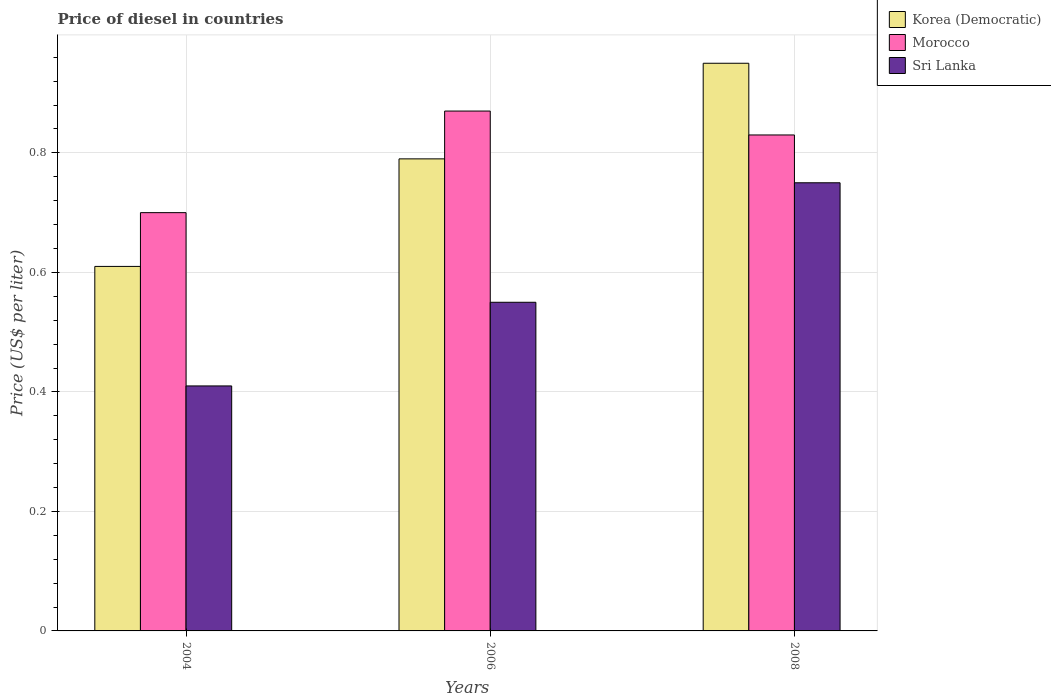Are the number of bars per tick equal to the number of legend labels?
Keep it short and to the point. Yes. Are the number of bars on each tick of the X-axis equal?
Provide a succinct answer. Yes. How many bars are there on the 1st tick from the left?
Provide a short and direct response. 3. What is the label of the 1st group of bars from the left?
Provide a short and direct response. 2004. In how many cases, is the number of bars for a given year not equal to the number of legend labels?
Offer a very short reply. 0. What is the price of diesel in Morocco in 2008?
Offer a terse response. 0.83. Across all years, what is the maximum price of diesel in Morocco?
Your answer should be compact. 0.87. Across all years, what is the minimum price of diesel in Korea (Democratic)?
Keep it short and to the point. 0.61. In which year was the price of diesel in Sri Lanka maximum?
Offer a terse response. 2008. What is the total price of diesel in Sri Lanka in the graph?
Offer a very short reply. 1.71. What is the difference between the price of diesel in Sri Lanka in 2004 and that in 2006?
Your answer should be very brief. -0.14. What is the difference between the price of diesel in Sri Lanka in 2008 and the price of diesel in Korea (Democratic) in 2006?
Your answer should be very brief. -0.04. What is the average price of diesel in Sri Lanka per year?
Provide a short and direct response. 0.57. In the year 2008, what is the difference between the price of diesel in Korea (Democratic) and price of diesel in Sri Lanka?
Ensure brevity in your answer.  0.2. What is the ratio of the price of diesel in Korea (Democratic) in 2004 to that in 2008?
Your answer should be compact. 0.64. Is the price of diesel in Korea (Democratic) in 2006 less than that in 2008?
Your response must be concise. Yes. Is the difference between the price of diesel in Korea (Democratic) in 2006 and 2008 greater than the difference between the price of diesel in Sri Lanka in 2006 and 2008?
Provide a succinct answer. Yes. What is the difference between the highest and the second highest price of diesel in Sri Lanka?
Ensure brevity in your answer.  0.2. What is the difference between the highest and the lowest price of diesel in Morocco?
Your answer should be compact. 0.17. What does the 3rd bar from the left in 2008 represents?
Your response must be concise. Sri Lanka. What does the 1st bar from the right in 2006 represents?
Offer a terse response. Sri Lanka. Is it the case that in every year, the sum of the price of diesel in Morocco and price of diesel in Korea (Democratic) is greater than the price of diesel in Sri Lanka?
Your answer should be very brief. Yes. How many years are there in the graph?
Your answer should be very brief. 3. Does the graph contain any zero values?
Ensure brevity in your answer.  No. Where does the legend appear in the graph?
Make the answer very short. Top right. What is the title of the graph?
Give a very brief answer. Price of diesel in countries. What is the label or title of the X-axis?
Your answer should be very brief. Years. What is the label or title of the Y-axis?
Your answer should be compact. Price (US$ per liter). What is the Price (US$ per liter) of Korea (Democratic) in 2004?
Your answer should be very brief. 0.61. What is the Price (US$ per liter) of Morocco in 2004?
Provide a succinct answer. 0.7. What is the Price (US$ per liter) of Sri Lanka in 2004?
Your response must be concise. 0.41. What is the Price (US$ per liter) of Korea (Democratic) in 2006?
Provide a short and direct response. 0.79. What is the Price (US$ per liter) of Morocco in 2006?
Your response must be concise. 0.87. What is the Price (US$ per liter) of Sri Lanka in 2006?
Offer a very short reply. 0.55. What is the Price (US$ per liter) in Korea (Democratic) in 2008?
Ensure brevity in your answer.  0.95. What is the Price (US$ per liter) in Morocco in 2008?
Your response must be concise. 0.83. Across all years, what is the maximum Price (US$ per liter) in Korea (Democratic)?
Ensure brevity in your answer.  0.95. Across all years, what is the maximum Price (US$ per liter) in Morocco?
Keep it short and to the point. 0.87. Across all years, what is the minimum Price (US$ per liter) of Korea (Democratic)?
Your response must be concise. 0.61. Across all years, what is the minimum Price (US$ per liter) of Morocco?
Make the answer very short. 0.7. Across all years, what is the minimum Price (US$ per liter) of Sri Lanka?
Offer a terse response. 0.41. What is the total Price (US$ per liter) in Korea (Democratic) in the graph?
Your answer should be compact. 2.35. What is the total Price (US$ per liter) of Morocco in the graph?
Provide a short and direct response. 2.4. What is the total Price (US$ per liter) of Sri Lanka in the graph?
Offer a terse response. 1.71. What is the difference between the Price (US$ per liter) of Korea (Democratic) in 2004 and that in 2006?
Your answer should be compact. -0.18. What is the difference between the Price (US$ per liter) in Morocco in 2004 and that in 2006?
Make the answer very short. -0.17. What is the difference between the Price (US$ per liter) in Sri Lanka in 2004 and that in 2006?
Provide a succinct answer. -0.14. What is the difference between the Price (US$ per liter) of Korea (Democratic) in 2004 and that in 2008?
Your answer should be compact. -0.34. What is the difference between the Price (US$ per liter) of Morocco in 2004 and that in 2008?
Provide a short and direct response. -0.13. What is the difference between the Price (US$ per liter) of Sri Lanka in 2004 and that in 2008?
Provide a short and direct response. -0.34. What is the difference between the Price (US$ per liter) in Korea (Democratic) in 2006 and that in 2008?
Your answer should be very brief. -0.16. What is the difference between the Price (US$ per liter) of Morocco in 2006 and that in 2008?
Keep it short and to the point. 0.04. What is the difference between the Price (US$ per liter) in Korea (Democratic) in 2004 and the Price (US$ per liter) in Morocco in 2006?
Your answer should be very brief. -0.26. What is the difference between the Price (US$ per liter) in Korea (Democratic) in 2004 and the Price (US$ per liter) in Sri Lanka in 2006?
Your response must be concise. 0.06. What is the difference between the Price (US$ per liter) of Morocco in 2004 and the Price (US$ per liter) of Sri Lanka in 2006?
Give a very brief answer. 0.15. What is the difference between the Price (US$ per liter) in Korea (Democratic) in 2004 and the Price (US$ per liter) in Morocco in 2008?
Provide a succinct answer. -0.22. What is the difference between the Price (US$ per liter) of Korea (Democratic) in 2004 and the Price (US$ per liter) of Sri Lanka in 2008?
Your response must be concise. -0.14. What is the difference between the Price (US$ per liter) in Korea (Democratic) in 2006 and the Price (US$ per liter) in Morocco in 2008?
Offer a terse response. -0.04. What is the difference between the Price (US$ per liter) in Korea (Democratic) in 2006 and the Price (US$ per liter) in Sri Lanka in 2008?
Your answer should be very brief. 0.04. What is the difference between the Price (US$ per liter) in Morocco in 2006 and the Price (US$ per liter) in Sri Lanka in 2008?
Offer a terse response. 0.12. What is the average Price (US$ per liter) of Korea (Democratic) per year?
Ensure brevity in your answer.  0.78. What is the average Price (US$ per liter) of Morocco per year?
Your response must be concise. 0.8. What is the average Price (US$ per liter) in Sri Lanka per year?
Ensure brevity in your answer.  0.57. In the year 2004, what is the difference between the Price (US$ per liter) of Korea (Democratic) and Price (US$ per liter) of Morocco?
Your answer should be very brief. -0.09. In the year 2004, what is the difference between the Price (US$ per liter) of Morocco and Price (US$ per liter) of Sri Lanka?
Provide a succinct answer. 0.29. In the year 2006, what is the difference between the Price (US$ per liter) of Korea (Democratic) and Price (US$ per liter) of Morocco?
Your answer should be compact. -0.08. In the year 2006, what is the difference between the Price (US$ per liter) in Korea (Democratic) and Price (US$ per liter) in Sri Lanka?
Provide a short and direct response. 0.24. In the year 2006, what is the difference between the Price (US$ per liter) in Morocco and Price (US$ per liter) in Sri Lanka?
Your response must be concise. 0.32. In the year 2008, what is the difference between the Price (US$ per liter) of Korea (Democratic) and Price (US$ per liter) of Morocco?
Your response must be concise. 0.12. In the year 2008, what is the difference between the Price (US$ per liter) in Morocco and Price (US$ per liter) in Sri Lanka?
Your answer should be compact. 0.08. What is the ratio of the Price (US$ per liter) in Korea (Democratic) in 2004 to that in 2006?
Make the answer very short. 0.77. What is the ratio of the Price (US$ per liter) in Morocco in 2004 to that in 2006?
Ensure brevity in your answer.  0.8. What is the ratio of the Price (US$ per liter) of Sri Lanka in 2004 to that in 2006?
Offer a terse response. 0.75. What is the ratio of the Price (US$ per liter) in Korea (Democratic) in 2004 to that in 2008?
Ensure brevity in your answer.  0.64. What is the ratio of the Price (US$ per liter) in Morocco in 2004 to that in 2008?
Make the answer very short. 0.84. What is the ratio of the Price (US$ per liter) of Sri Lanka in 2004 to that in 2008?
Your response must be concise. 0.55. What is the ratio of the Price (US$ per liter) of Korea (Democratic) in 2006 to that in 2008?
Offer a very short reply. 0.83. What is the ratio of the Price (US$ per liter) of Morocco in 2006 to that in 2008?
Offer a terse response. 1.05. What is the ratio of the Price (US$ per liter) of Sri Lanka in 2006 to that in 2008?
Offer a very short reply. 0.73. What is the difference between the highest and the second highest Price (US$ per liter) in Korea (Democratic)?
Your answer should be compact. 0.16. What is the difference between the highest and the lowest Price (US$ per liter) of Korea (Democratic)?
Your response must be concise. 0.34. What is the difference between the highest and the lowest Price (US$ per liter) of Morocco?
Give a very brief answer. 0.17. What is the difference between the highest and the lowest Price (US$ per liter) in Sri Lanka?
Give a very brief answer. 0.34. 